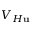<formula> <loc_0><loc_0><loc_500><loc_500>V _ { H u }</formula> 